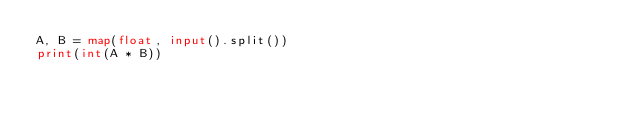<code> <loc_0><loc_0><loc_500><loc_500><_Python_>A, B = map(float, input().split())
print(int(A * B))</code> 